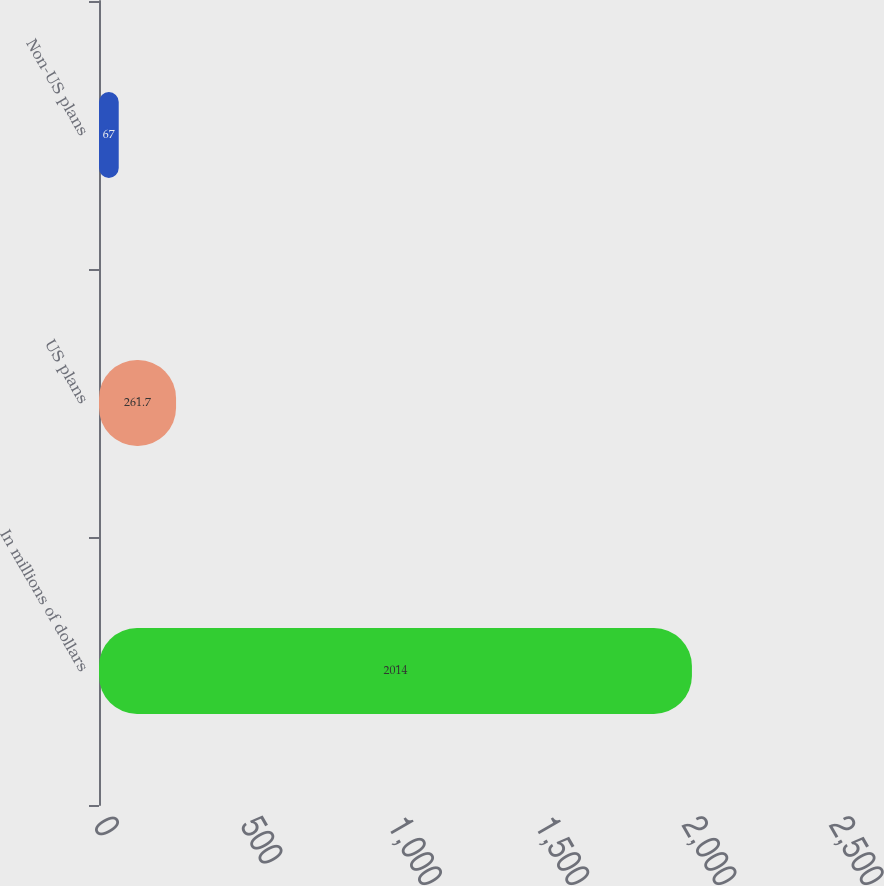<chart> <loc_0><loc_0><loc_500><loc_500><bar_chart><fcel>In millions of dollars<fcel>US plans<fcel>Non-US plans<nl><fcel>2014<fcel>261.7<fcel>67<nl></chart> 